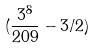<formula> <loc_0><loc_0><loc_500><loc_500>( \frac { 3 ^ { 8 } } { 2 0 9 } - 3 / 2 )</formula> 